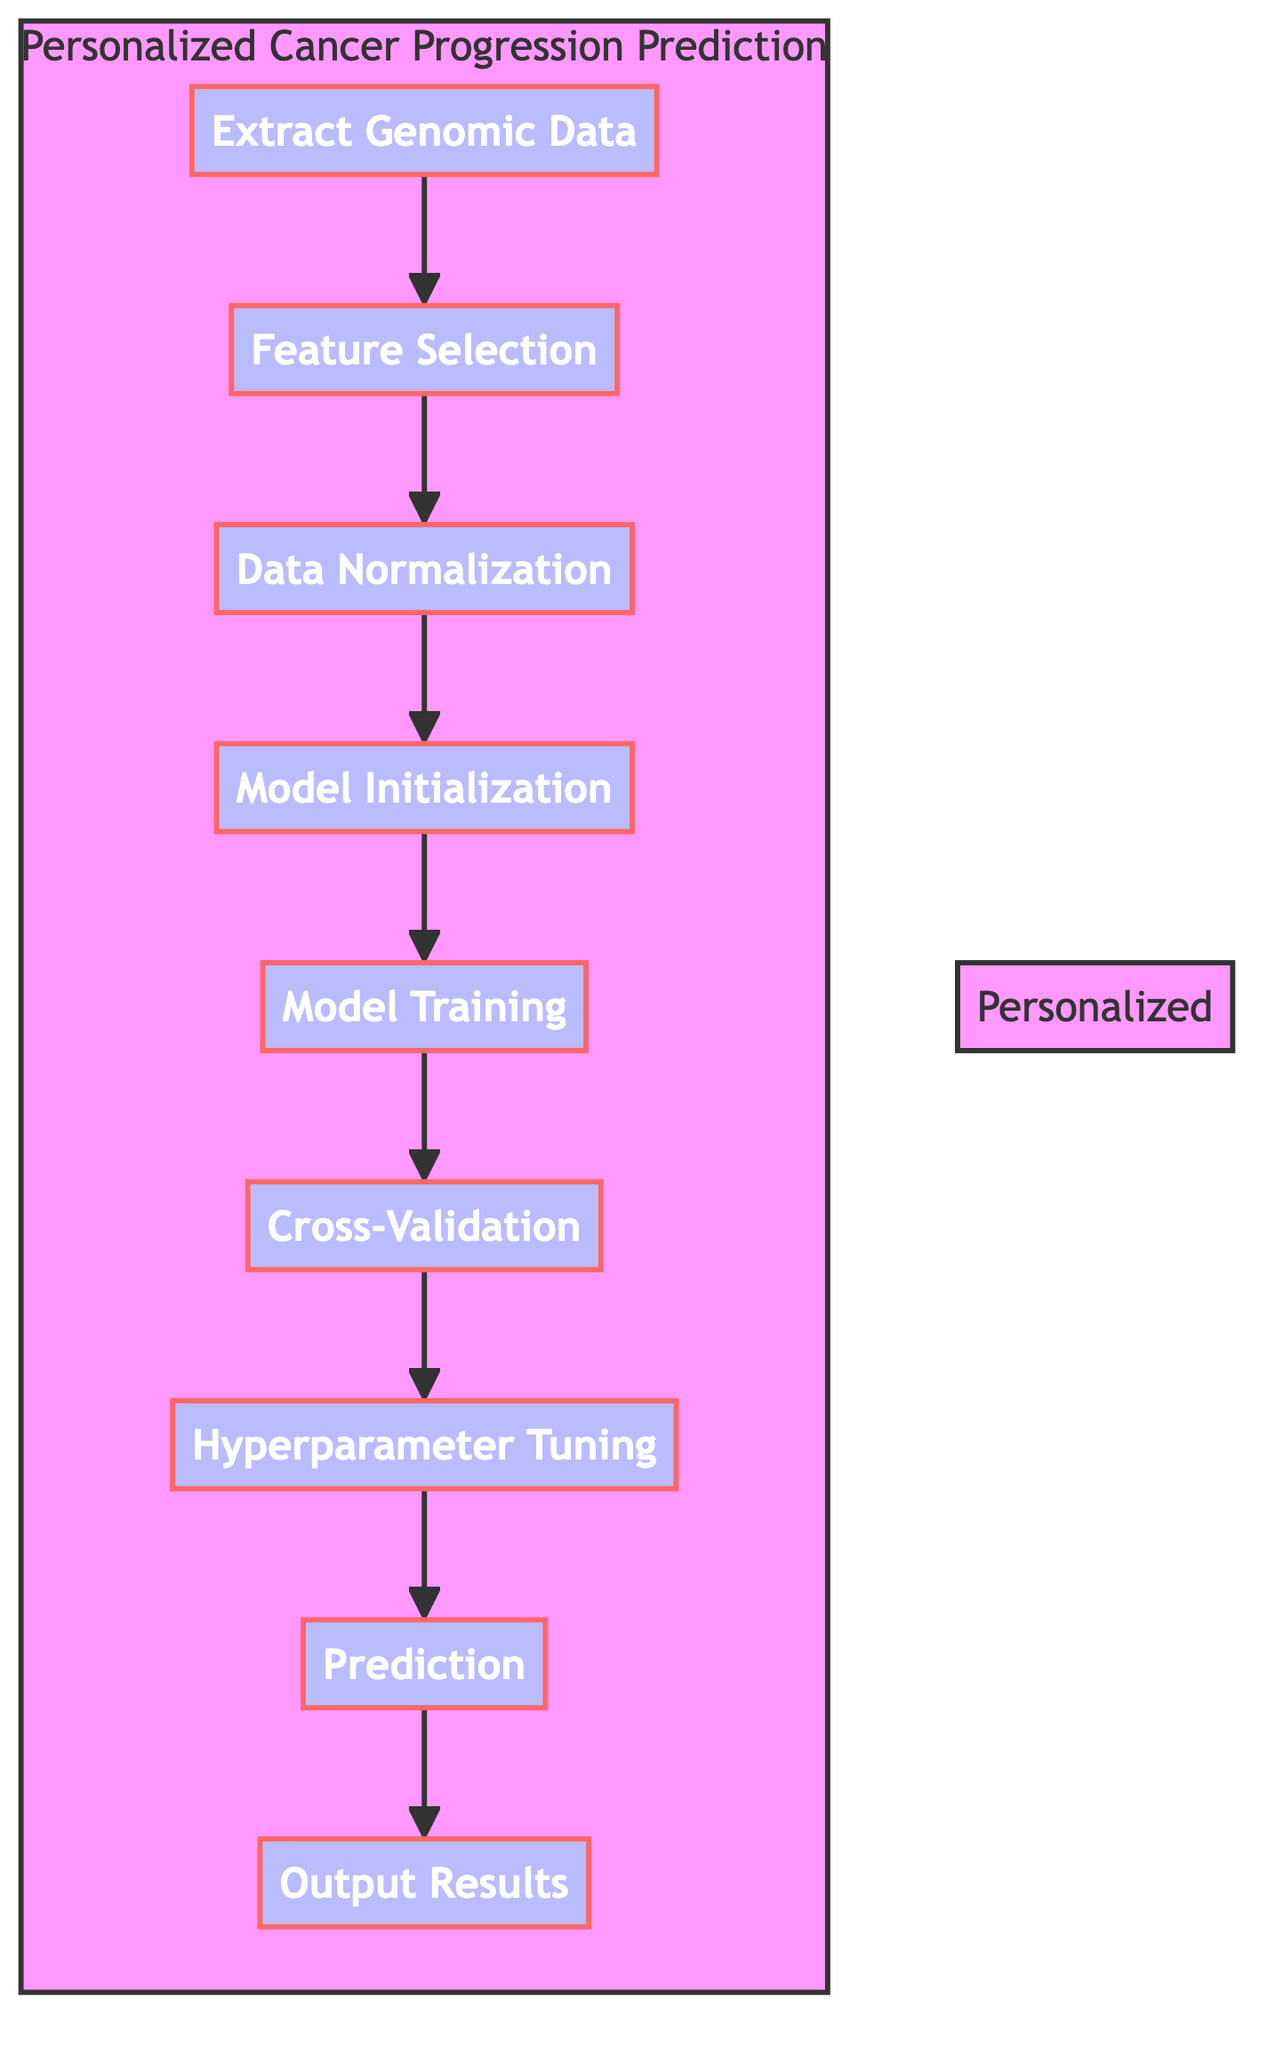What is the first step in the diagram? The first node in the flowchart is labeled "Extract Genomic Data," indicating that this is the starting point of the process for personalized cancer progression prediction.
Answer: Extract Genomic Data How many nodes are in the diagram? By counting each unique step outlined in the flowchart, we can enumerate that there are nine distinct nodes in total.
Answer: Nine What comes directly after "Feature Selection"? The flow of the diagram indicates that "Data Normalization" is the subsequent step that follows "Feature Selection," making it a direct connection in the process.
Answer: Data Normalization Which step is responsible for model evaluation? "Cross-Validation" is the designated step in the process where the model's performance is evaluated, ensuring that it generalizes well to new data without fitting too closely to the training data.
Answer: Cross-Validation What is the final output of the process? The last node in the flowchart is labeled "Output Results," signaling that this step generates and displays the predictions related to cancer progression for individual patients.
Answer: Output Results Are hyperparameters optimized before or after model training? According to the diagram's flow, "Hyperparameter Tuning" occurs after "Model Training," reinforcing that the model needs to be trained first before fine-tuning its parameters for improved performance.
Answer: After How many steps must be completed before making a prediction? By reviewing the flowchart, we can ascertain that a total of six steps, from "Extract Genomic Data" to "Hyperparameter Tuning," must be completed prior to reaching the "Prediction" stage, making this a sequential process.
Answer: Six Which step directly follows "Model Initialization"? The diagram shows that "Model Training" immediately follows after "Model Initialization," indicating that once the model is set up, it needs to be trained on the data right afterward.
Answer: Model Training What type of model initialization is implied in the diagram? The description for "Model Initialization" refers to initializing models such as a neural network or random forest model, signifying that these are potential methods for the prediction process.
Answer: Neural network or random forest model 